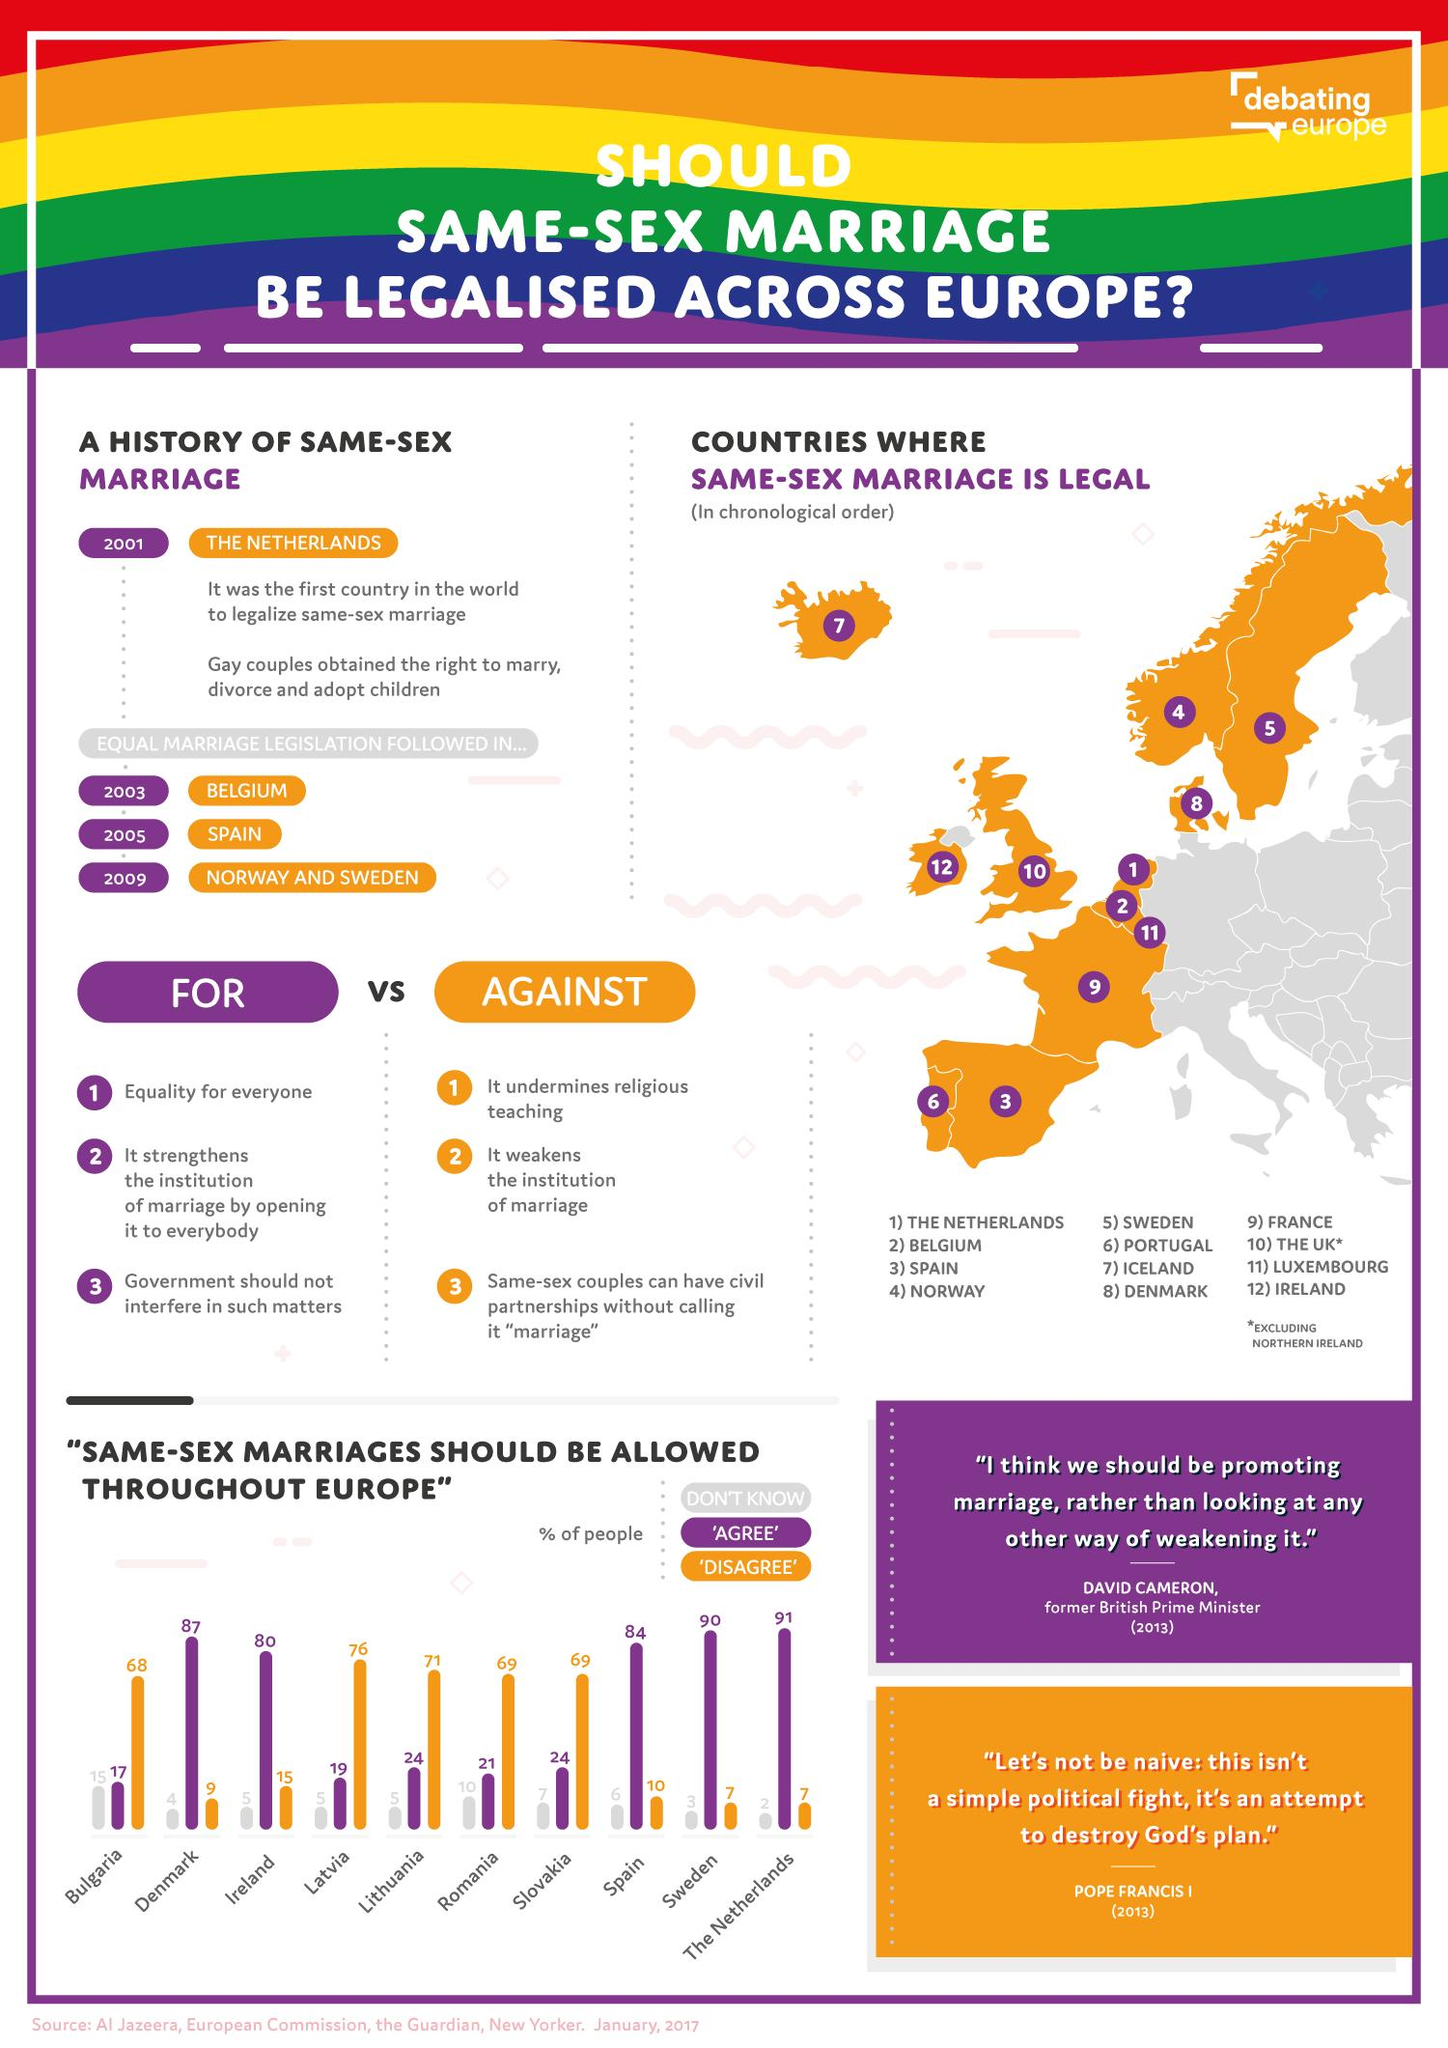Mention a couple of crucial points in this snapshot. Bulgaria has the least amount of its population that supports same-sex marriage. The bar chart uses purple to denote people who don't know if same-sex marriage should be allowed in Europe. It is estimated that approximately 5 countries have a majority of their population dissenting for same-sex marriage. The Netherlands and Sweden have the least amount of people who disagree with allowing same-sex marriage. A significant number of countries have a majority of their population in agreement with same-sex marriage. 